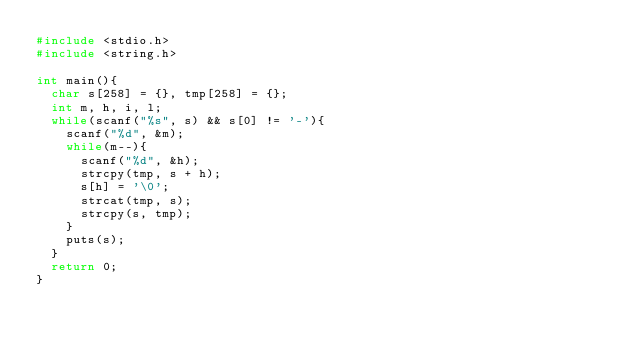<code> <loc_0><loc_0><loc_500><loc_500><_C_>#include <stdio.h>
#include <string.h>

int main(){
  char s[258] = {}, tmp[258] = {};
  int m, h, i, l;
  while(scanf("%s", s) && s[0] != '-'){
    scanf("%d", &m);
    while(m--){
      scanf("%d", &h);
      strcpy(tmp, s + h);
      s[h] = '\0';
      strcat(tmp, s);
      strcpy(s, tmp);
    }
    puts(s);
  }
  return 0;
}</code> 